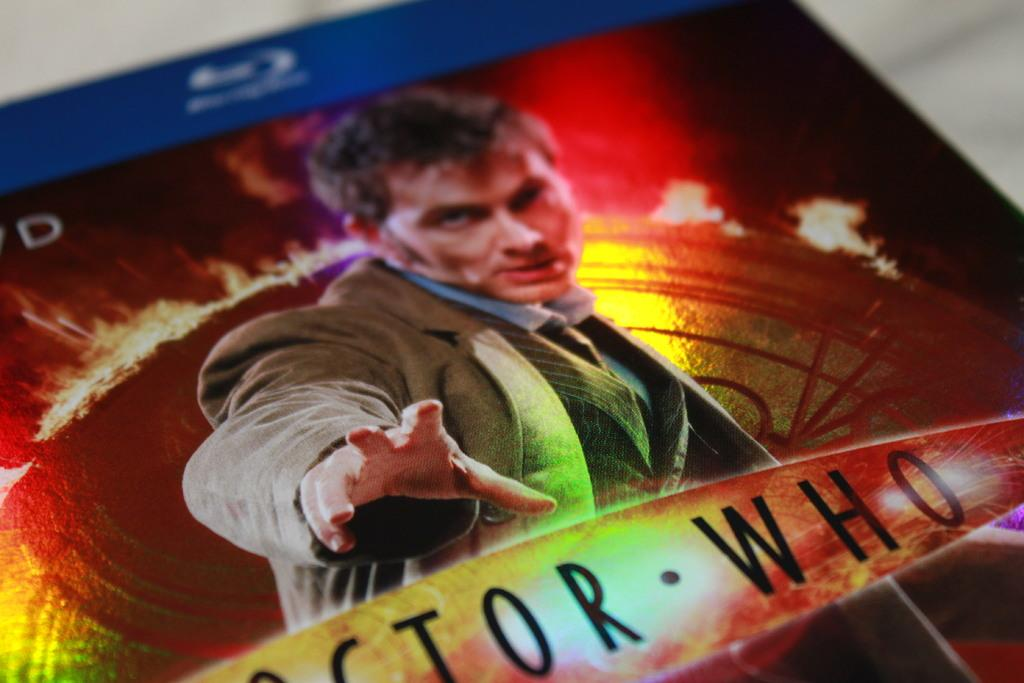<image>
Share a concise interpretation of the image provided. a picture that is showing someone from the show Doctor Who 